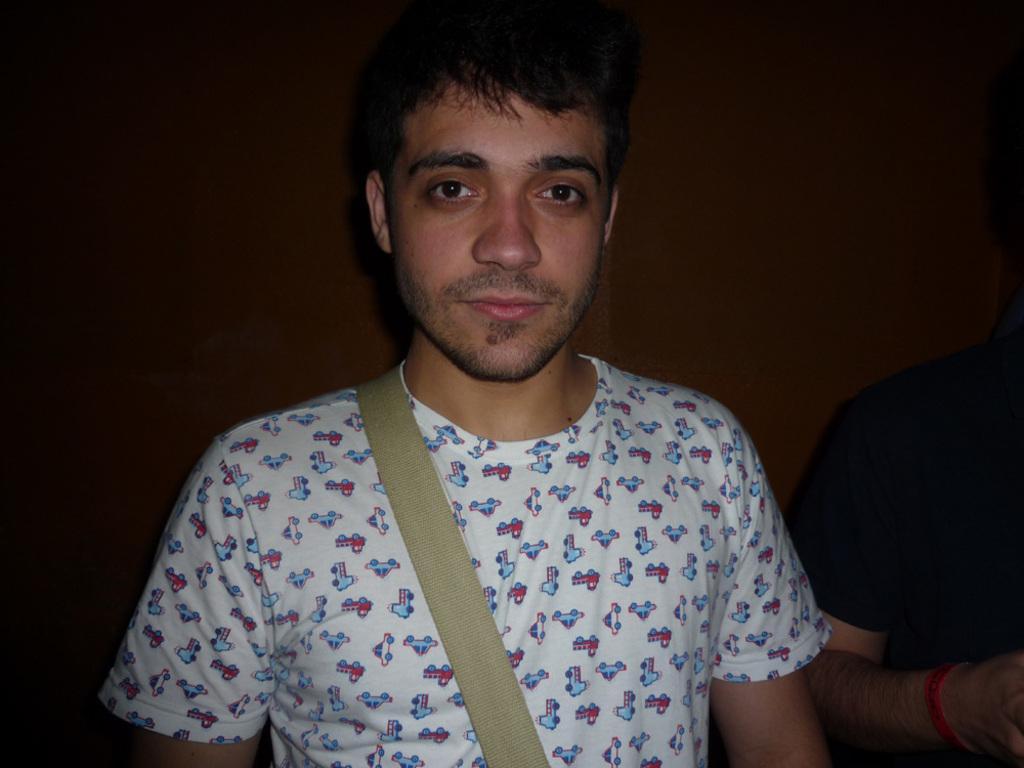In one or two sentences, can you explain what this image depicts? In this image we can see two person's, a person is wearing a white shirt and a person is wearing a black shirt and a wall in the background. 